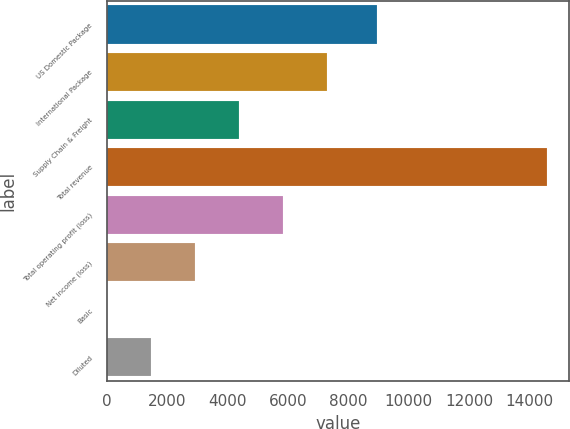Convert chart to OTSL. <chart><loc_0><loc_0><loc_500><loc_500><bar_chart><fcel>US Domestic Package<fcel>International Package<fcel>Supply Chain & Freight<fcel>Total revenue<fcel>Total operating profit (loss)<fcel>Net income (loss)<fcel>Basic<fcel>Diluted<nl><fcel>8933<fcel>7286.43<fcel>4372.59<fcel>14571<fcel>5829.51<fcel>2915.67<fcel>1.83<fcel>1458.75<nl></chart> 